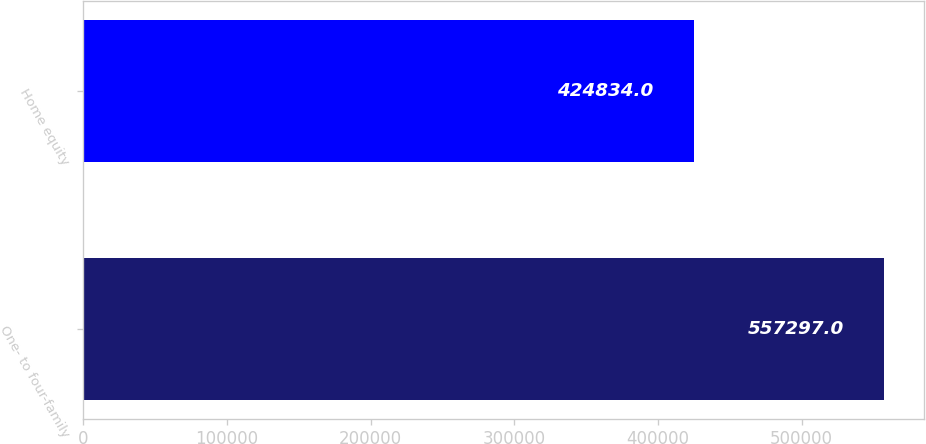Convert chart. <chart><loc_0><loc_0><loc_500><loc_500><bar_chart><fcel>One- to four-family<fcel>Home equity<nl><fcel>557297<fcel>424834<nl></chart> 